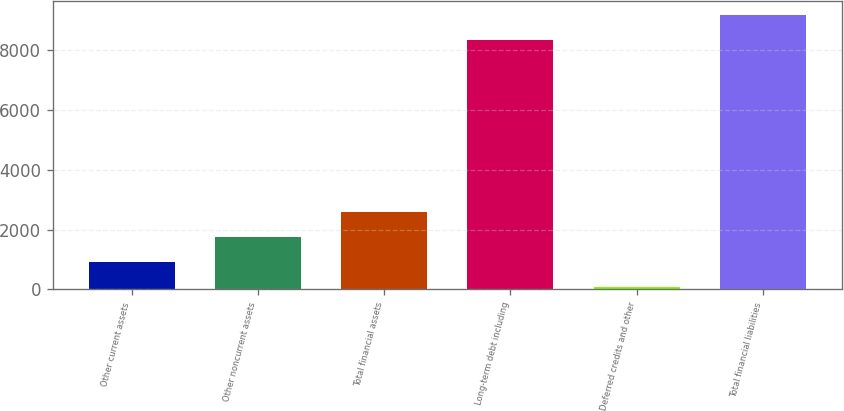Convert chart. <chart><loc_0><loc_0><loc_500><loc_500><bar_chart><fcel>Other current assets<fcel>Other noncurrent assets<fcel>Total financial assets<fcel>Long-term debt including<fcel>Deferred credits and other<fcel>Total financial liabilities<nl><fcel>902.4<fcel>1738.8<fcel>2575.2<fcel>8364<fcel>66<fcel>9200.4<nl></chart> 